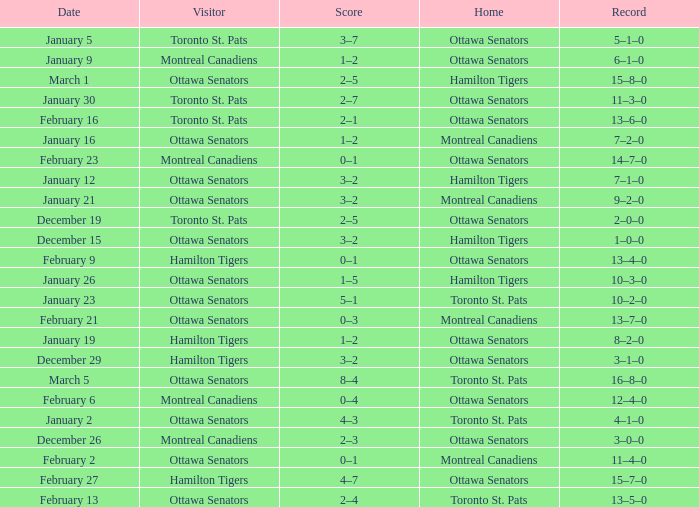Which home team had a visitor of Ottawa Senators with a score of 1–5? Hamilton Tigers. 